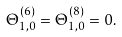Convert formula to latex. <formula><loc_0><loc_0><loc_500><loc_500>\Theta _ { 1 , 0 } ^ { \left ( 6 \right ) } = \Theta _ { 1 , 0 } ^ { \left ( 8 \right ) } = 0 .</formula> 